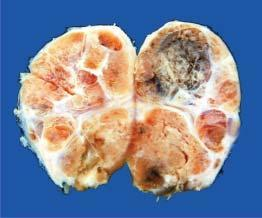what is enlarged and nodular?
Answer the question using a single word or phrase. Thyroid gland 